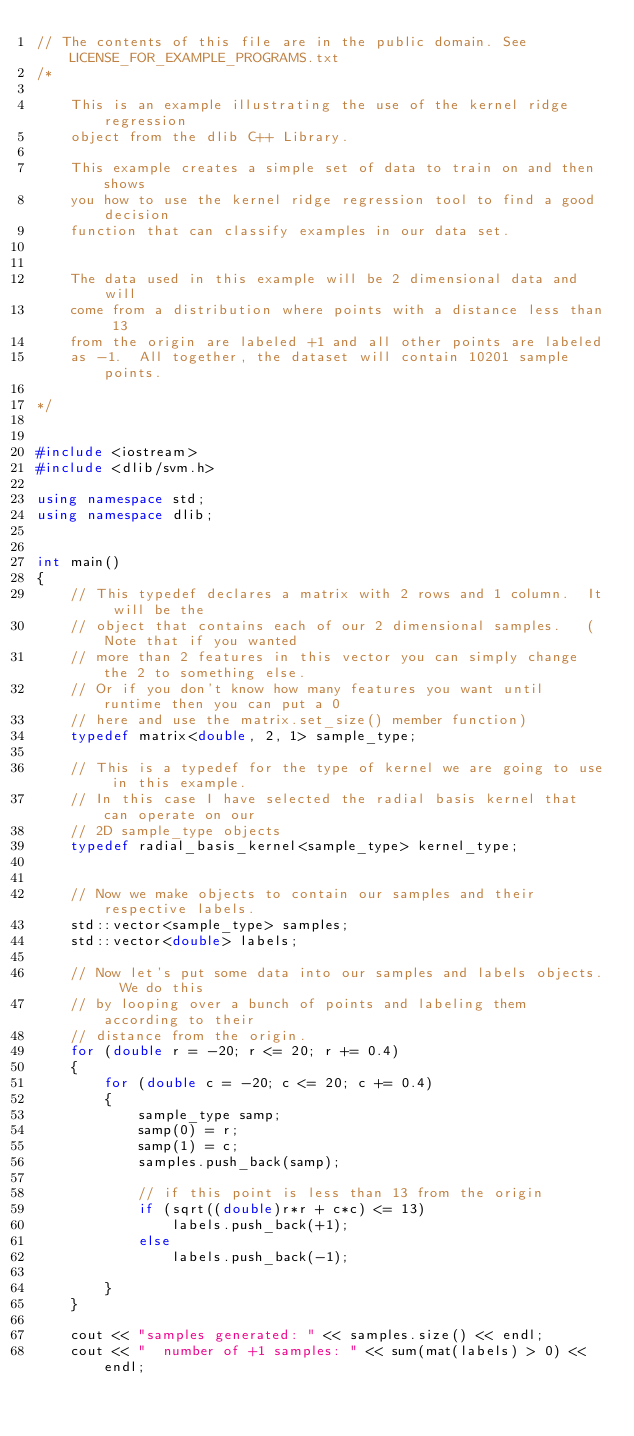<code> <loc_0><loc_0><loc_500><loc_500><_C++_>// The contents of this file are in the public domain. See LICENSE_FOR_EXAMPLE_PROGRAMS.txt
/*

    This is an example illustrating the use of the kernel ridge regression 
    object from the dlib C++ Library.  

    This example creates a simple set of data to train on and then shows
    you how to use the kernel ridge regression tool to find a good decision 
    function that can classify examples in our data set.


    The data used in this example will be 2 dimensional data and will
    come from a distribution where points with a distance less than 13
    from the origin are labeled +1 and all other points are labeled
    as -1.  All together, the dataset will contain 10201 sample points.
        
*/


#include <iostream>
#include <dlib/svm.h>

using namespace std;
using namespace dlib;


int main()
{
    // This typedef declares a matrix with 2 rows and 1 column.  It will be the
    // object that contains each of our 2 dimensional samples.   (Note that if you wanted 
    // more than 2 features in this vector you can simply change the 2 to something else.
    // Or if you don't know how many features you want until runtime then you can put a 0
    // here and use the matrix.set_size() member function)
    typedef matrix<double, 2, 1> sample_type;

    // This is a typedef for the type of kernel we are going to use in this example.
    // In this case I have selected the radial basis kernel that can operate on our
    // 2D sample_type objects
    typedef radial_basis_kernel<sample_type> kernel_type;


    // Now we make objects to contain our samples and their respective labels.
    std::vector<sample_type> samples;
    std::vector<double> labels;

    // Now let's put some data into our samples and labels objects.  We do this
    // by looping over a bunch of points and labeling them according to their
    // distance from the origin.
    for (double r = -20; r <= 20; r += 0.4)
    {
        for (double c = -20; c <= 20; c += 0.4)
        {
            sample_type samp;
            samp(0) = r;
            samp(1) = c;
            samples.push_back(samp);

            // if this point is less than 13 from the origin
            if (sqrt((double)r*r + c*c) <= 13)
                labels.push_back(+1);
            else
                labels.push_back(-1);

        }
    }

    cout << "samples generated: " << samples.size() << endl;
    cout << "  number of +1 samples: " << sum(mat(labels) > 0) << endl;</code> 